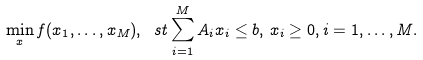Convert formula to latex. <formula><loc_0><loc_0><loc_500><loc_500>\min _ { x } f ( x _ { 1 } , \dots , x _ { M } ) , \ s t \sum _ { i = 1 } ^ { M } A _ { i } x _ { i } \leq b , \, x _ { i } \geq 0 , i = 1 , \dots , M .</formula> 